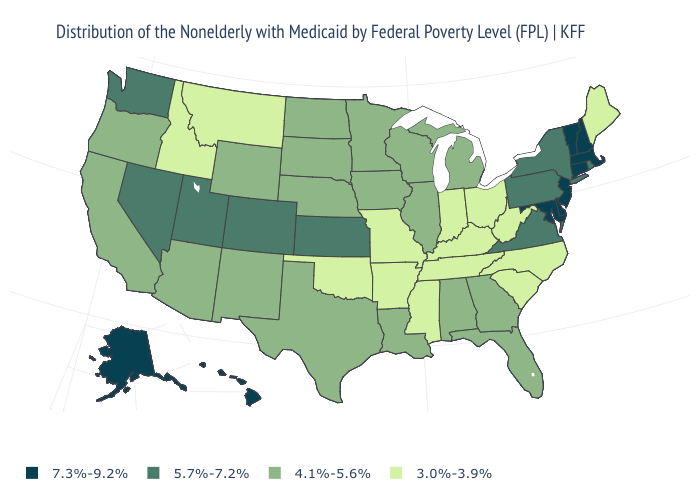What is the highest value in the USA?
Write a very short answer. 7.3%-9.2%. What is the value of New Mexico?
Answer briefly. 4.1%-5.6%. Does North Carolina have a lower value than Idaho?
Keep it brief. No. What is the value of Georgia?
Concise answer only. 4.1%-5.6%. Among the states that border Connecticut , does New York have the lowest value?
Be succinct. Yes. Is the legend a continuous bar?
Quick response, please. No. What is the highest value in the USA?
Quick response, please. 7.3%-9.2%. What is the value of Maine?
Give a very brief answer. 3.0%-3.9%. Which states have the lowest value in the USA?
Give a very brief answer. Arkansas, Idaho, Indiana, Kentucky, Maine, Mississippi, Missouri, Montana, North Carolina, Ohio, Oklahoma, South Carolina, Tennessee, West Virginia. What is the value of Utah?
Be succinct. 5.7%-7.2%. Name the states that have a value in the range 3.0%-3.9%?
Answer briefly. Arkansas, Idaho, Indiana, Kentucky, Maine, Mississippi, Missouri, Montana, North Carolina, Ohio, Oklahoma, South Carolina, Tennessee, West Virginia. What is the highest value in the South ?
Answer briefly. 7.3%-9.2%. What is the lowest value in the USA?
Answer briefly. 3.0%-3.9%. What is the lowest value in the MidWest?
Give a very brief answer. 3.0%-3.9%. How many symbols are there in the legend?
Short answer required. 4. 